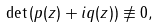<formula> <loc_0><loc_0><loc_500><loc_500>\det \, ( p ( z ) + i q ( z ) ) \not \equiv 0 ,</formula> 